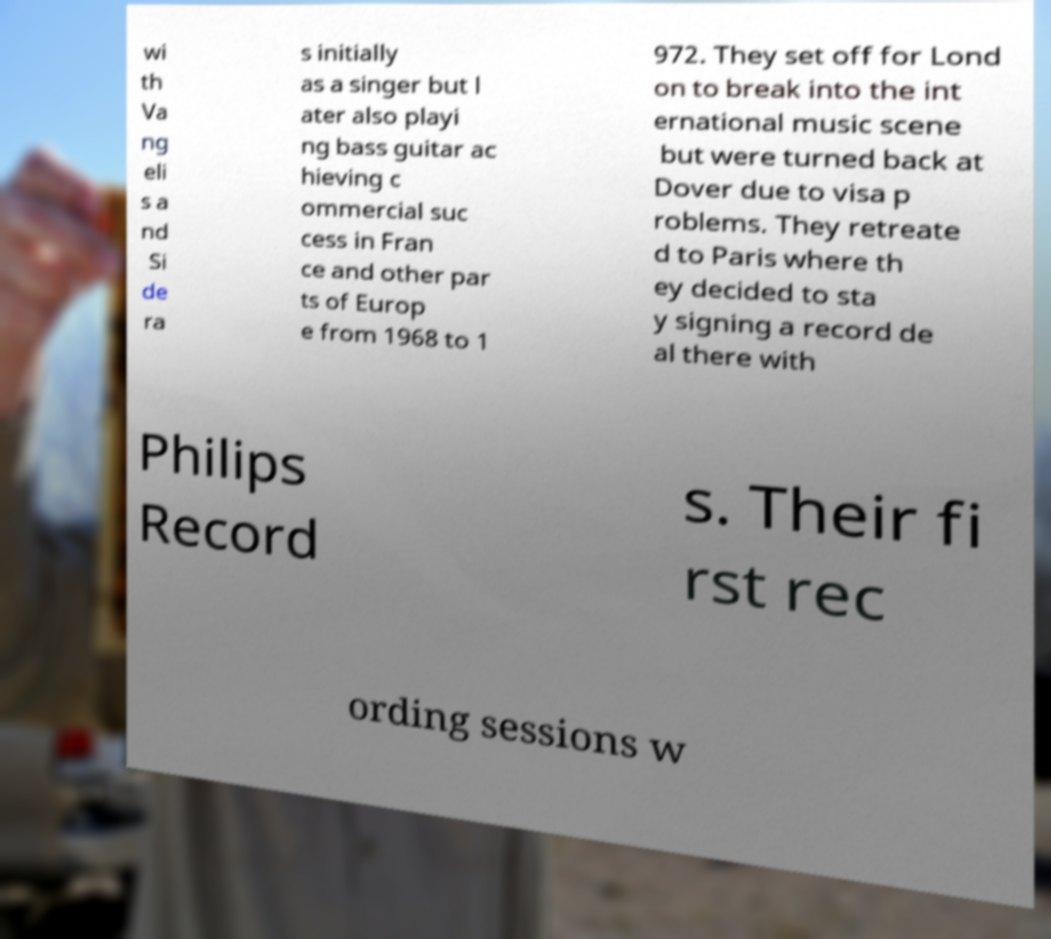Could you assist in decoding the text presented in this image and type it out clearly? wi th Va ng eli s a nd Si de ra s initially as a singer but l ater also playi ng bass guitar ac hieving c ommercial suc cess in Fran ce and other par ts of Europ e from 1968 to 1 972. They set off for Lond on to break into the int ernational music scene but were turned back at Dover due to visa p roblems. They retreate d to Paris where th ey decided to sta y signing a record de al there with Philips Record s. Their fi rst rec ording sessions w 